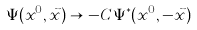<formula> <loc_0><loc_0><loc_500><loc_500>\Psi ( x ^ { 0 } , \vec { x } ) \to - C \Psi ^ { \ast } ( x ^ { 0 } , - \vec { x } )</formula> 